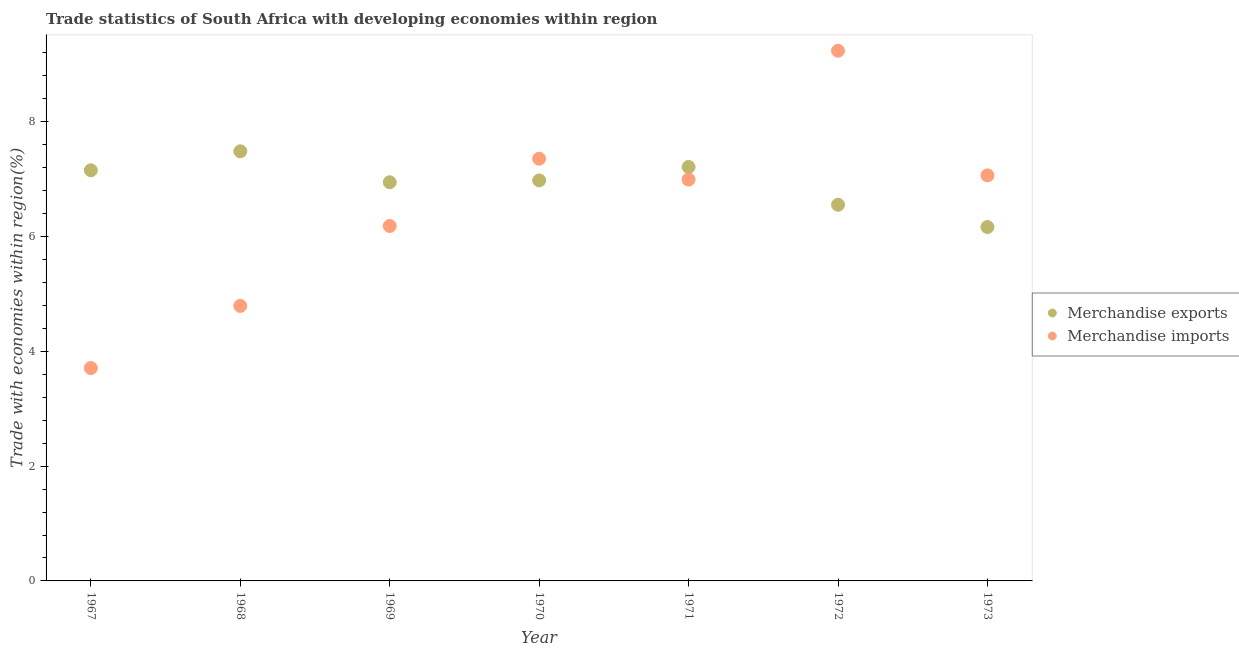What is the merchandise exports in 1967?
Give a very brief answer. 7.16. Across all years, what is the maximum merchandise exports?
Offer a very short reply. 7.49. Across all years, what is the minimum merchandise exports?
Offer a very short reply. 6.17. In which year was the merchandise exports maximum?
Give a very brief answer. 1968. In which year was the merchandise exports minimum?
Ensure brevity in your answer.  1973. What is the total merchandise imports in the graph?
Your response must be concise. 45.35. What is the difference between the merchandise imports in 1970 and that in 1971?
Your answer should be compact. 0.36. What is the difference between the merchandise exports in 1968 and the merchandise imports in 1970?
Keep it short and to the point. 0.13. What is the average merchandise exports per year?
Offer a very short reply. 6.93. In the year 1970, what is the difference between the merchandise exports and merchandise imports?
Provide a succinct answer. -0.38. What is the ratio of the merchandise exports in 1969 to that in 1973?
Your response must be concise. 1.13. What is the difference between the highest and the second highest merchandise imports?
Your answer should be compact. 1.88. What is the difference between the highest and the lowest merchandise imports?
Your response must be concise. 5.53. In how many years, is the merchandise imports greater than the average merchandise imports taken over all years?
Your answer should be compact. 4. Is the merchandise exports strictly greater than the merchandise imports over the years?
Offer a very short reply. No. How many dotlines are there?
Your answer should be compact. 2. How many years are there in the graph?
Ensure brevity in your answer.  7. Are the values on the major ticks of Y-axis written in scientific E-notation?
Give a very brief answer. No. Does the graph contain grids?
Offer a terse response. No. How many legend labels are there?
Offer a very short reply. 2. How are the legend labels stacked?
Your response must be concise. Vertical. What is the title of the graph?
Give a very brief answer. Trade statistics of South Africa with developing economies within region. Does "Resident workers" appear as one of the legend labels in the graph?
Give a very brief answer. No. What is the label or title of the Y-axis?
Your response must be concise. Trade with economies within region(%). What is the Trade with economies within region(%) of Merchandise exports in 1967?
Ensure brevity in your answer.  7.16. What is the Trade with economies within region(%) in Merchandise imports in 1967?
Give a very brief answer. 3.71. What is the Trade with economies within region(%) in Merchandise exports in 1968?
Provide a short and direct response. 7.49. What is the Trade with economies within region(%) in Merchandise imports in 1968?
Provide a succinct answer. 4.79. What is the Trade with economies within region(%) in Merchandise exports in 1969?
Provide a succinct answer. 6.95. What is the Trade with economies within region(%) in Merchandise imports in 1969?
Offer a terse response. 6.19. What is the Trade with economies within region(%) in Merchandise exports in 1970?
Keep it short and to the point. 6.98. What is the Trade with economies within region(%) of Merchandise imports in 1970?
Make the answer very short. 7.36. What is the Trade with economies within region(%) of Merchandise exports in 1971?
Provide a succinct answer. 7.21. What is the Trade with economies within region(%) in Merchandise imports in 1971?
Ensure brevity in your answer.  6.99. What is the Trade with economies within region(%) in Merchandise exports in 1972?
Give a very brief answer. 6.56. What is the Trade with economies within region(%) in Merchandise imports in 1972?
Provide a short and direct response. 9.24. What is the Trade with economies within region(%) in Merchandise exports in 1973?
Give a very brief answer. 6.17. What is the Trade with economies within region(%) of Merchandise imports in 1973?
Provide a succinct answer. 7.07. Across all years, what is the maximum Trade with economies within region(%) of Merchandise exports?
Ensure brevity in your answer.  7.49. Across all years, what is the maximum Trade with economies within region(%) in Merchandise imports?
Make the answer very short. 9.24. Across all years, what is the minimum Trade with economies within region(%) in Merchandise exports?
Offer a very short reply. 6.17. Across all years, what is the minimum Trade with economies within region(%) of Merchandise imports?
Keep it short and to the point. 3.71. What is the total Trade with economies within region(%) of Merchandise exports in the graph?
Your answer should be very brief. 48.51. What is the total Trade with economies within region(%) in Merchandise imports in the graph?
Offer a terse response. 45.35. What is the difference between the Trade with economies within region(%) of Merchandise exports in 1967 and that in 1968?
Provide a short and direct response. -0.33. What is the difference between the Trade with economies within region(%) of Merchandise imports in 1967 and that in 1968?
Your response must be concise. -1.08. What is the difference between the Trade with economies within region(%) of Merchandise exports in 1967 and that in 1969?
Offer a terse response. 0.21. What is the difference between the Trade with economies within region(%) of Merchandise imports in 1967 and that in 1969?
Offer a very short reply. -2.48. What is the difference between the Trade with economies within region(%) in Merchandise exports in 1967 and that in 1970?
Provide a succinct answer. 0.18. What is the difference between the Trade with economies within region(%) of Merchandise imports in 1967 and that in 1970?
Make the answer very short. -3.65. What is the difference between the Trade with economies within region(%) of Merchandise exports in 1967 and that in 1971?
Your response must be concise. -0.06. What is the difference between the Trade with economies within region(%) in Merchandise imports in 1967 and that in 1971?
Offer a very short reply. -3.28. What is the difference between the Trade with economies within region(%) of Merchandise exports in 1967 and that in 1972?
Provide a succinct answer. 0.6. What is the difference between the Trade with economies within region(%) of Merchandise imports in 1967 and that in 1972?
Offer a very short reply. -5.53. What is the difference between the Trade with economies within region(%) of Merchandise imports in 1967 and that in 1973?
Your answer should be compact. -3.36. What is the difference between the Trade with economies within region(%) of Merchandise exports in 1968 and that in 1969?
Provide a short and direct response. 0.54. What is the difference between the Trade with economies within region(%) in Merchandise imports in 1968 and that in 1969?
Provide a succinct answer. -1.39. What is the difference between the Trade with economies within region(%) of Merchandise exports in 1968 and that in 1970?
Keep it short and to the point. 0.51. What is the difference between the Trade with economies within region(%) in Merchandise imports in 1968 and that in 1970?
Provide a succinct answer. -2.57. What is the difference between the Trade with economies within region(%) of Merchandise exports in 1968 and that in 1971?
Keep it short and to the point. 0.27. What is the difference between the Trade with economies within region(%) of Merchandise imports in 1968 and that in 1971?
Keep it short and to the point. -2.2. What is the difference between the Trade with economies within region(%) of Merchandise exports in 1968 and that in 1972?
Provide a succinct answer. 0.93. What is the difference between the Trade with economies within region(%) of Merchandise imports in 1968 and that in 1972?
Ensure brevity in your answer.  -4.45. What is the difference between the Trade with economies within region(%) of Merchandise exports in 1968 and that in 1973?
Provide a succinct answer. 1.32. What is the difference between the Trade with economies within region(%) in Merchandise imports in 1968 and that in 1973?
Provide a succinct answer. -2.27. What is the difference between the Trade with economies within region(%) in Merchandise exports in 1969 and that in 1970?
Provide a succinct answer. -0.03. What is the difference between the Trade with economies within region(%) in Merchandise imports in 1969 and that in 1970?
Provide a succinct answer. -1.17. What is the difference between the Trade with economies within region(%) in Merchandise exports in 1969 and that in 1971?
Make the answer very short. -0.27. What is the difference between the Trade with economies within region(%) in Merchandise imports in 1969 and that in 1971?
Provide a short and direct response. -0.81. What is the difference between the Trade with economies within region(%) of Merchandise exports in 1969 and that in 1972?
Make the answer very short. 0.39. What is the difference between the Trade with economies within region(%) of Merchandise imports in 1969 and that in 1972?
Your response must be concise. -3.05. What is the difference between the Trade with economies within region(%) of Merchandise exports in 1969 and that in 1973?
Provide a succinct answer. 0.78. What is the difference between the Trade with economies within region(%) of Merchandise imports in 1969 and that in 1973?
Provide a short and direct response. -0.88. What is the difference between the Trade with economies within region(%) of Merchandise exports in 1970 and that in 1971?
Give a very brief answer. -0.23. What is the difference between the Trade with economies within region(%) in Merchandise imports in 1970 and that in 1971?
Offer a very short reply. 0.36. What is the difference between the Trade with economies within region(%) of Merchandise exports in 1970 and that in 1972?
Keep it short and to the point. 0.42. What is the difference between the Trade with economies within region(%) in Merchandise imports in 1970 and that in 1972?
Keep it short and to the point. -1.88. What is the difference between the Trade with economies within region(%) of Merchandise exports in 1970 and that in 1973?
Your response must be concise. 0.81. What is the difference between the Trade with economies within region(%) of Merchandise imports in 1970 and that in 1973?
Keep it short and to the point. 0.29. What is the difference between the Trade with economies within region(%) in Merchandise exports in 1971 and that in 1972?
Your response must be concise. 0.66. What is the difference between the Trade with economies within region(%) in Merchandise imports in 1971 and that in 1972?
Your answer should be compact. -2.25. What is the difference between the Trade with economies within region(%) in Merchandise exports in 1971 and that in 1973?
Your response must be concise. 1.05. What is the difference between the Trade with economies within region(%) in Merchandise imports in 1971 and that in 1973?
Your response must be concise. -0.07. What is the difference between the Trade with economies within region(%) of Merchandise exports in 1972 and that in 1973?
Keep it short and to the point. 0.39. What is the difference between the Trade with economies within region(%) in Merchandise imports in 1972 and that in 1973?
Give a very brief answer. 2.17. What is the difference between the Trade with economies within region(%) of Merchandise exports in 1967 and the Trade with economies within region(%) of Merchandise imports in 1968?
Ensure brevity in your answer.  2.36. What is the difference between the Trade with economies within region(%) in Merchandise exports in 1967 and the Trade with economies within region(%) in Merchandise imports in 1969?
Your answer should be very brief. 0.97. What is the difference between the Trade with economies within region(%) of Merchandise exports in 1967 and the Trade with economies within region(%) of Merchandise imports in 1970?
Offer a terse response. -0.2. What is the difference between the Trade with economies within region(%) of Merchandise exports in 1967 and the Trade with economies within region(%) of Merchandise imports in 1971?
Ensure brevity in your answer.  0.16. What is the difference between the Trade with economies within region(%) in Merchandise exports in 1967 and the Trade with economies within region(%) in Merchandise imports in 1972?
Your response must be concise. -2.08. What is the difference between the Trade with economies within region(%) in Merchandise exports in 1967 and the Trade with economies within region(%) in Merchandise imports in 1973?
Provide a succinct answer. 0.09. What is the difference between the Trade with economies within region(%) in Merchandise exports in 1968 and the Trade with economies within region(%) in Merchandise imports in 1969?
Give a very brief answer. 1.3. What is the difference between the Trade with economies within region(%) of Merchandise exports in 1968 and the Trade with economies within region(%) of Merchandise imports in 1970?
Give a very brief answer. 0.13. What is the difference between the Trade with economies within region(%) of Merchandise exports in 1968 and the Trade with economies within region(%) of Merchandise imports in 1971?
Make the answer very short. 0.49. What is the difference between the Trade with economies within region(%) in Merchandise exports in 1968 and the Trade with economies within region(%) in Merchandise imports in 1972?
Your response must be concise. -1.75. What is the difference between the Trade with economies within region(%) of Merchandise exports in 1968 and the Trade with economies within region(%) of Merchandise imports in 1973?
Provide a short and direct response. 0.42. What is the difference between the Trade with economies within region(%) of Merchandise exports in 1969 and the Trade with economies within region(%) of Merchandise imports in 1970?
Offer a terse response. -0.41. What is the difference between the Trade with economies within region(%) of Merchandise exports in 1969 and the Trade with economies within region(%) of Merchandise imports in 1971?
Your answer should be very brief. -0.05. What is the difference between the Trade with economies within region(%) in Merchandise exports in 1969 and the Trade with economies within region(%) in Merchandise imports in 1972?
Make the answer very short. -2.29. What is the difference between the Trade with economies within region(%) of Merchandise exports in 1969 and the Trade with economies within region(%) of Merchandise imports in 1973?
Provide a succinct answer. -0.12. What is the difference between the Trade with economies within region(%) of Merchandise exports in 1970 and the Trade with economies within region(%) of Merchandise imports in 1971?
Ensure brevity in your answer.  -0.01. What is the difference between the Trade with economies within region(%) of Merchandise exports in 1970 and the Trade with economies within region(%) of Merchandise imports in 1972?
Offer a terse response. -2.26. What is the difference between the Trade with economies within region(%) in Merchandise exports in 1970 and the Trade with economies within region(%) in Merchandise imports in 1973?
Give a very brief answer. -0.09. What is the difference between the Trade with economies within region(%) in Merchandise exports in 1971 and the Trade with economies within region(%) in Merchandise imports in 1972?
Keep it short and to the point. -2.03. What is the difference between the Trade with economies within region(%) of Merchandise exports in 1971 and the Trade with economies within region(%) of Merchandise imports in 1973?
Make the answer very short. 0.15. What is the difference between the Trade with economies within region(%) of Merchandise exports in 1972 and the Trade with economies within region(%) of Merchandise imports in 1973?
Offer a terse response. -0.51. What is the average Trade with economies within region(%) of Merchandise exports per year?
Your answer should be very brief. 6.93. What is the average Trade with economies within region(%) in Merchandise imports per year?
Provide a succinct answer. 6.48. In the year 1967, what is the difference between the Trade with economies within region(%) in Merchandise exports and Trade with economies within region(%) in Merchandise imports?
Keep it short and to the point. 3.45. In the year 1968, what is the difference between the Trade with economies within region(%) in Merchandise exports and Trade with economies within region(%) in Merchandise imports?
Your response must be concise. 2.69. In the year 1969, what is the difference between the Trade with economies within region(%) in Merchandise exports and Trade with economies within region(%) in Merchandise imports?
Offer a terse response. 0.76. In the year 1970, what is the difference between the Trade with economies within region(%) of Merchandise exports and Trade with economies within region(%) of Merchandise imports?
Your answer should be very brief. -0.38. In the year 1971, what is the difference between the Trade with economies within region(%) in Merchandise exports and Trade with economies within region(%) in Merchandise imports?
Ensure brevity in your answer.  0.22. In the year 1972, what is the difference between the Trade with economies within region(%) in Merchandise exports and Trade with economies within region(%) in Merchandise imports?
Ensure brevity in your answer.  -2.68. In the year 1973, what is the difference between the Trade with economies within region(%) of Merchandise exports and Trade with economies within region(%) of Merchandise imports?
Make the answer very short. -0.9. What is the ratio of the Trade with economies within region(%) of Merchandise exports in 1967 to that in 1968?
Ensure brevity in your answer.  0.96. What is the ratio of the Trade with economies within region(%) of Merchandise imports in 1967 to that in 1968?
Make the answer very short. 0.77. What is the ratio of the Trade with economies within region(%) in Merchandise imports in 1967 to that in 1969?
Provide a short and direct response. 0.6. What is the ratio of the Trade with economies within region(%) in Merchandise exports in 1967 to that in 1970?
Offer a very short reply. 1.03. What is the ratio of the Trade with economies within region(%) in Merchandise imports in 1967 to that in 1970?
Your answer should be very brief. 0.5. What is the ratio of the Trade with economies within region(%) in Merchandise exports in 1967 to that in 1971?
Give a very brief answer. 0.99. What is the ratio of the Trade with economies within region(%) of Merchandise imports in 1967 to that in 1971?
Keep it short and to the point. 0.53. What is the ratio of the Trade with economies within region(%) of Merchandise exports in 1967 to that in 1972?
Provide a succinct answer. 1.09. What is the ratio of the Trade with economies within region(%) of Merchandise imports in 1967 to that in 1972?
Give a very brief answer. 0.4. What is the ratio of the Trade with economies within region(%) in Merchandise exports in 1967 to that in 1973?
Your response must be concise. 1.16. What is the ratio of the Trade with economies within region(%) in Merchandise imports in 1967 to that in 1973?
Offer a terse response. 0.52. What is the ratio of the Trade with economies within region(%) in Merchandise exports in 1968 to that in 1969?
Give a very brief answer. 1.08. What is the ratio of the Trade with economies within region(%) of Merchandise imports in 1968 to that in 1969?
Provide a short and direct response. 0.77. What is the ratio of the Trade with economies within region(%) of Merchandise exports in 1968 to that in 1970?
Provide a succinct answer. 1.07. What is the ratio of the Trade with economies within region(%) of Merchandise imports in 1968 to that in 1970?
Your answer should be very brief. 0.65. What is the ratio of the Trade with economies within region(%) in Merchandise exports in 1968 to that in 1971?
Give a very brief answer. 1.04. What is the ratio of the Trade with economies within region(%) in Merchandise imports in 1968 to that in 1971?
Offer a very short reply. 0.69. What is the ratio of the Trade with economies within region(%) of Merchandise exports in 1968 to that in 1972?
Offer a very short reply. 1.14. What is the ratio of the Trade with economies within region(%) of Merchandise imports in 1968 to that in 1972?
Provide a succinct answer. 0.52. What is the ratio of the Trade with economies within region(%) of Merchandise exports in 1968 to that in 1973?
Your answer should be very brief. 1.21. What is the ratio of the Trade with economies within region(%) of Merchandise imports in 1968 to that in 1973?
Make the answer very short. 0.68. What is the ratio of the Trade with economies within region(%) in Merchandise imports in 1969 to that in 1970?
Ensure brevity in your answer.  0.84. What is the ratio of the Trade with economies within region(%) in Merchandise exports in 1969 to that in 1971?
Provide a short and direct response. 0.96. What is the ratio of the Trade with economies within region(%) of Merchandise imports in 1969 to that in 1971?
Give a very brief answer. 0.88. What is the ratio of the Trade with economies within region(%) of Merchandise exports in 1969 to that in 1972?
Your answer should be very brief. 1.06. What is the ratio of the Trade with economies within region(%) of Merchandise imports in 1969 to that in 1972?
Keep it short and to the point. 0.67. What is the ratio of the Trade with economies within region(%) in Merchandise exports in 1969 to that in 1973?
Your answer should be very brief. 1.13. What is the ratio of the Trade with economies within region(%) in Merchandise imports in 1969 to that in 1973?
Your answer should be compact. 0.88. What is the ratio of the Trade with economies within region(%) of Merchandise exports in 1970 to that in 1971?
Your response must be concise. 0.97. What is the ratio of the Trade with economies within region(%) of Merchandise imports in 1970 to that in 1971?
Make the answer very short. 1.05. What is the ratio of the Trade with economies within region(%) of Merchandise exports in 1970 to that in 1972?
Offer a very short reply. 1.06. What is the ratio of the Trade with economies within region(%) of Merchandise imports in 1970 to that in 1972?
Provide a short and direct response. 0.8. What is the ratio of the Trade with economies within region(%) in Merchandise exports in 1970 to that in 1973?
Make the answer very short. 1.13. What is the ratio of the Trade with economies within region(%) in Merchandise imports in 1970 to that in 1973?
Provide a succinct answer. 1.04. What is the ratio of the Trade with economies within region(%) of Merchandise exports in 1971 to that in 1972?
Your answer should be very brief. 1.1. What is the ratio of the Trade with economies within region(%) of Merchandise imports in 1971 to that in 1972?
Give a very brief answer. 0.76. What is the ratio of the Trade with economies within region(%) in Merchandise exports in 1971 to that in 1973?
Make the answer very short. 1.17. What is the ratio of the Trade with economies within region(%) of Merchandise exports in 1972 to that in 1973?
Your answer should be compact. 1.06. What is the ratio of the Trade with economies within region(%) in Merchandise imports in 1972 to that in 1973?
Ensure brevity in your answer.  1.31. What is the difference between the highest and the second highest Trade with economies within region(%) in Merchandise exports?
Keep it short and to the point. 0.27. What is the difference between the highest and the second highest Trade with economies within region(%) in Merchandise imports?
Ensure brevity in your answer.  1.88. What is the difference between the highest and the lowest Trade with economies within region(%) of Merchandise exports?
Make the answer very short. 1.32. What is the difference between the highest and the lowest Trade with economies within region(%) in Merchandise imports?
Make the answer very short. 5.53. 